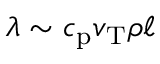Convert formula to latex. <formula><loc_0><loc_0><loc_500><loc_500>\lambda \sim c _ { p } v _ { T } \rho \ell</formula> 